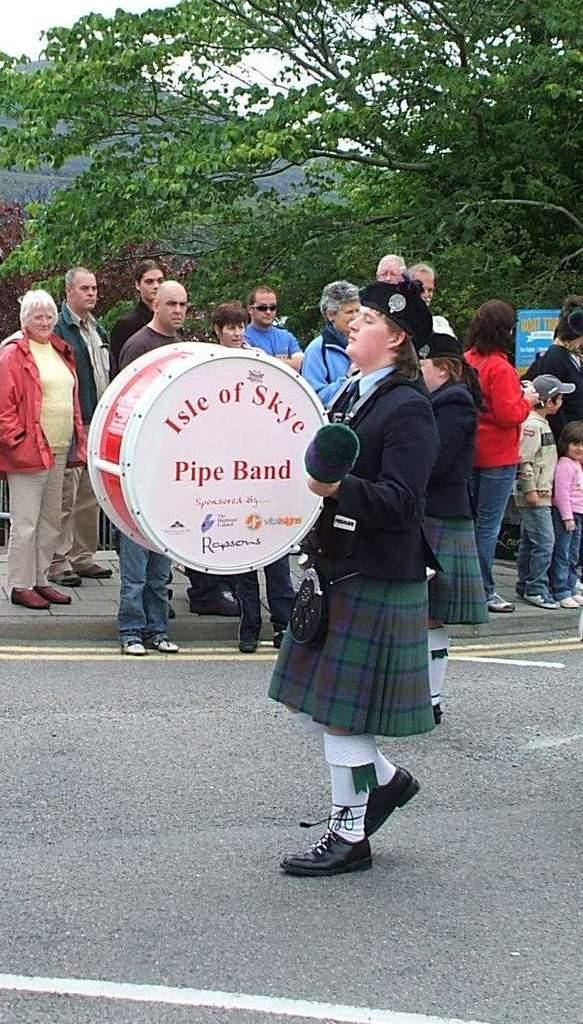Can you describe this image briefly? This image is clicked on the roads. There is a woman walking and playing drums. She is wearing a black suit. In the background, there are many people standing and there are many trees. 